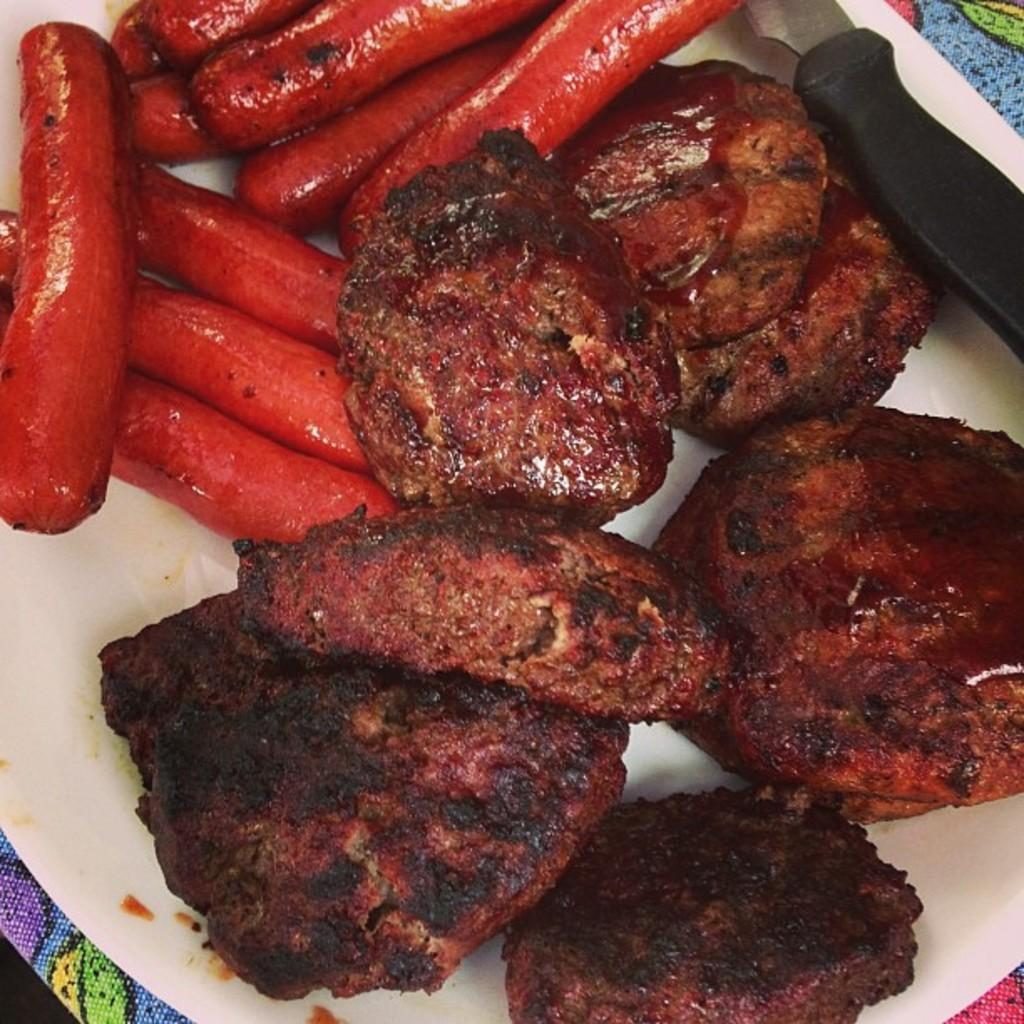What is the main food item visible on the plate in the image? The specific food item cannot be determined from the provided facts. What utensil is present in the image? There is a knife in the image. What type of weather can be seen in the image? There is no information about the weather in the image, as it only features a food item on a plate and a knife. 